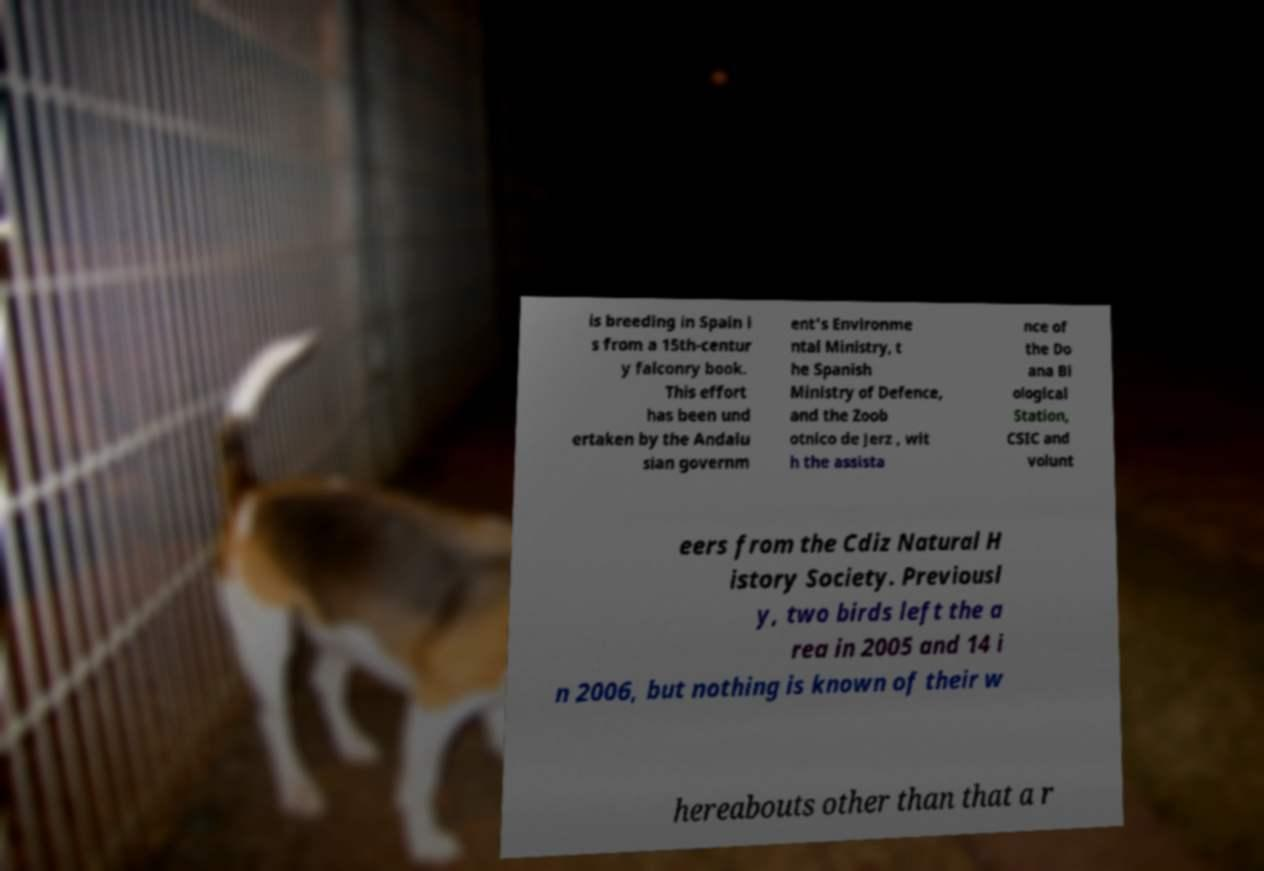Can you accurately transcribe the text from the provided image for me? is breeding in Spain i s from a 15th-centur y falconry book. This effort has been und ertaken by the Andalu sian governm ent's Environme ntal Ministry, t he Spanish Ministry of Defence, and the Zoob otnico de Jerz , wit h the assista nce of the Do ana Bi ological Station, CSIC and volunt eers from the Cdiz Natural H istory Society. Previousl y, two birds left the a rea in 2005 and 14 i n 2006, but nothing is known of their w hereabouts other than that a r 